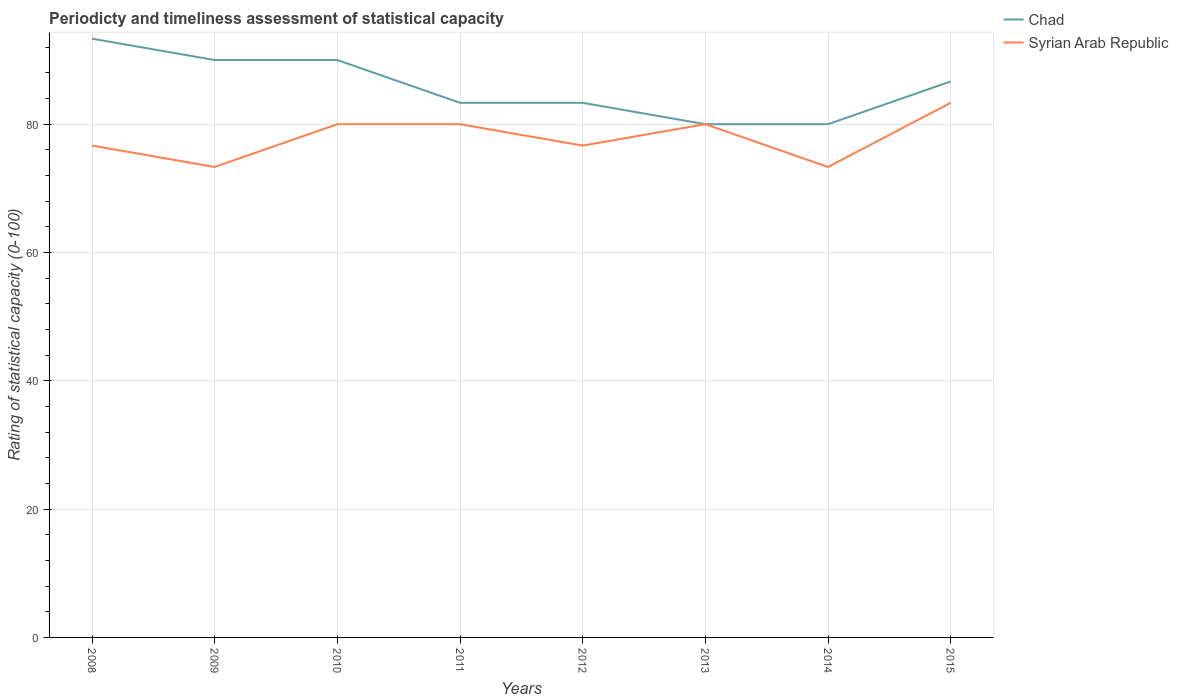Across all years, what is the maximum rating of statistical capacity in Chad?
Offer a very short reply. 80. What is the total rating of statistical capacity in Chad in the graph?
Make the answer very short. -6.67. What is the difference between the highest and the second highest rating of statistical capacity in Chad?
Your answer should be compact. 13.33. What is the difference between the highest and the lowest rating of statistical capacity in Syrian Arab Republic?
Provide a succinct answer. 4. Is the rating of statistical capacity in Chad strictly greater than the rating of statistical capacity in Syrian Arab Republic over the years?
Your response must be concise. No. How many lines are there?
Offer a very short reply. 2. How many years are there in the graph?
Provide a succinct answer. 8. What is the difference between two consecutive major ticks on the Y-axis?
Make the answer very short. 20. Does the graph contain any zero values?
Ensure brevity in your answer.  No. Does the graph contain grids?
Offer a terse response. Yes. How many legend labels are there?
Offer a very short reply. 2. How are the legend labels stacked?
Your response must be concise. Vertical. What is the title of the graph?
Your response must be concise. Periodicty and timeliness assessment of statistical capacity. Does "Australia" appear as one of the legend labels in the graph?
Offer a very short reply. No. What is the label or title of the Y-axis?
Provide a succinct answer. Rating of statistical capacity (0-100). What is the Rating of statistical capacity (0-100) in Chad in 2008?
Offer a terse response. 93.33. What is the Rating of statistical capacity (0-100) in Syrian Arab Republic in 2008?
Give a very brief answer. 76.67. What is the Rating of statistical capacity (0-100) in Chad in 2009?
Your response must be concise. 90. What is the Rating of statistical capacity (0-100) of Syrian Arab Republic in 2009?
Keep it short and to the point. 73.33. What is the Rating of statistical capacity (0-100) of Chad in 2010?
Ensure brevity in your answer.  90. What is the Rating of statistical capacity (0-100) of Chad in 2011?
Provide a succinct answer. 83.33. What is the Rating of statistical capacity (0-100) of Syrian Arab Republic in 2011?
Keep it short and to the point. 80. What is the Rating of statistical capacity (0-100) of Chad in 2012?
Provide a short and direct response. 83.33. What is the Rating of statistical capacity (0-100) in Syrian Arab Republic in 2012?
Provide a short and direct response. 76.67. What is the Rating of statistical capacity (0-100) of Chad in 2013?
Keep it short and to the point. 80. What is the Rating of statistical capacity (0-100) in Syrian Arab Republic in 2013?
Offer a terse response. 80. What is the Rating of statistical capacity (0-100) of Syrian Arab Republic in 2014?
Ensure brevity in your answer.  73.33. What is the Rating of statistical capacity (0-100) in Chad in 2015?
Your response must be concise. 86.67. What is the Rating of statistical capacity (0-100) of Syrian Arab Republic in 2015?
Make the answer very short. 83.33. Across all years, what is the maximum Rating of statistical capacity (0-100) in Chad?
Offer a terse response. 93.33. Across all years, what is the maximum Rating of statistical capacity (0-100) in Syrian Arab Republic?
Provide a succinct answer. 83.33. Across all years, what is the minimum Rating of statistical capacity (0-100) of Syrian Arab Republic?
Keep it short and to the point. 73.33. What is the total Rating of statistical capacity (0-100) of Chad in the graph?
Offer a very short reply. 686.67. What is the total Rating of statistical capacity (0-100) in Syrian Arab Republic in the graph?
Offer a terse response. 623.33. What is the difference between the Rating of statistical capacity (0-100) in Chad in 2008 and that in 2011?
Provide a short and direct response. 10. What is the difference between the Rating of statistical capacity (0-100) in Syrian Arab Republic in 2008 and that in 2011?
Give a very brief answer. -3.33. What is the difference between the Rating of statistical capacity (0-100) of Chad in 2008 and that in 2012?
Your answer should be very brief. 10. What is the difference between the Rating of statistical capacity (0-100) of Syrian Arab Republic in 2008 and that in 2012?
Keep it short and to the point. 0. What is the difference between the Rating of statistical capacity (0-100) in Chad in 2008 and that in 2013?
Offer a very short reply. 13.33. What is the difference between the Rating of statistical capacity (0-100) in Syrian Arab Republic in 2008 and that in 2013?
Provide a succinct answer. -3.33. What is the difference between the Rating of statistical capacity (0-100) in Chad in 2008 and that in 2014?
Your answer should be very brief. 13.33. What is the difference between the Rating of statistical capacity (0-100) in Syrian Arab Republic in 2008 and that in 2014?
Ensure brevity in your answer.  3.33. What is the difference between the Rating of statistical capacity (0-100) of Chad in 2008 and that in 2015?
Offer a terse response. 6.67. What is the difference between the Rating of statistical capacity (0-100) of Syrian Arab Republic in 2008 and that in 2015?
Your response must be concise. -6.67. What is the difference between the Rating of statistical capacity (0-100) of Chad in 2009 and that in 2010?
Your response must be concise. 0. What is the difference between the Rating of statistical capacity (0-100) of Syrian Arab Republic in 2009 and that in 2010?
Ensure brevity in your answer.  -6.67. What is the difference between the Rating of statistical capacity (0-100) of Syrian Arab Republic in 2009 and that in 2011?
Your answer should be compact. -6.67. What is the difference between the Rating of statistical capacity (0-100) in Chad in 2009 and that in 2013?
Give a very brief answer. 10. What is the difference between the Rating of statistical capacity (0-100) in Syrian Arab Republic in 2009 and that in 2013?
Your answer should be very brief. -6.67. What is the difference between the Rating of statistical capacity (0-100) of Chad in 2009 and that in 2014?
Ensure brevity in your answer.  10. What is the difference between the Rating of statistical capacity (0-100) in Syrian Arab Republic in 2009 and that in 2014?
Offer a terse response. -0. What is the difference between the Rating of statistical capacity (0-100) of Chad in 2009 and that in 2015?
Give a very brief answer. 3.33. What is the difference between the Rating of statistical capacity (0-100) in Syrian Arab Republic in 2010 and that in 2011?
Give a very brief answer. 0. What is the difference between the Rating of statistical capacity (0-100) in Chad in 2010 and that in 2012?
Provide a short and direct response. 6.67. What is the difference between the Rating of statistical capacity (0-100) of Syrian Arab Republic in 2010 and that in 2012?
Keep it short and to the point. 3.33. What is the difference between the Rating of statistical capacity (0-100) of Chad in 2010 and that in 2013?
Give a very brief answer. 10. What is the difference between the Rating of statistical capacity (0-100) of Chad in 2010 and that in 2014?
Your response must be concise. 10. What is the difference between the Rating of statistical capacity (0-100) in Syrian Arab Republic in 2010 and that in 2014?
Provide a succinct answer. 6.67. What is the difference between the Rating of statistical capacity (0-100) in Chad in 2010 and that in 2015?
Your response must be concise. 3.33. What is the difference between the Rating of statistical capacity (0-100) in Chad in 2011 and that in 2015?
Make the answer very short. -3.33. What is the difference between the Rating of statistical capacity (0-100) in Syrian Arab Republic in 2012 and that in 2013?
Offer a very short reply. -3.33. What is the difference between the Rating of statistical capacity (0-100) of Chad in 2012 and that in 2014?
Your answer should be compact. 3.33. What is the difference between the Rating of statistical capacity (0-100) in Chad in 2012 and that in 2015?
Give a very brief answer. -3.33. What is the difference between the Rating of statistical capacity (0-100) of Syrian Arab Republic in 2012 and that in 2015?
Offer a terse response. -6.67. What is the difference between the Rating of statistical capacity (0-100) in Chad in 2013 and that in 2014?
Your answer should be compact. 0. What is the difference between the Rating of statistical capacity (0-100) of Syrian Arab Republic in 2013 and that in 2014?
Your answer should be compact. 6.67. What is the difference between the Rating of statistical capacity (0-100) of Chad in 2013 and that in 2015?
Provide a short and direct response. -6.67. What is the difference between the Rating of statistical capacity (0-100) of Syrian Arab Republic in 2013 and that in 2015?
Give a very brief answer. -3.33. What is the difference between the Rating of statistical capacity (0-100) of Chad in 2014 and that in 2015?
Give a very brief answer. -6.67. What is the difference between the Rating of statistical capacity (0-100) in Chad in 2008 and the Rating of statistical capacity (0-100) in Syrian Arab Republic in 2010?
Ensure brevity in your answer.  13.33. What is the difference between the Rating of statistical capacity (0-100) in Chad in 2008 and the Rating of statistical capacity (0-100) in Syrian Arab Republic in 2011?
Offer a terse response. 13.33. What is the difference between the Rating of statistical capacity (0-100) of Chad in 2008 and the Rating of statistical capacity (0-100) of Syrian Arab Republic in 2012?
Provide a succinct answer. 16.67. What is the difference between the Rating of statistical capacity (0-100) in Chad in 2008 and the Rating of statistical capacity (0-100) in Syrian Arab Republic in 2013?
Provide a short and direct response. 13.33. What is the difference between the Rating of statistical capacity (0-100) in Chad in 2008 and the Rating of statistical capacity (0-100) in Syrian Arab Republic in 2015?
Your response must be concise. 10. What is the difference between the Rating of statistical capacity (0-100) of Chad in 2009 and the Rating of statistical capacity (0-100) of Syrian Arab Republic in 2010?
Give a very brief answer. 10. What is the difference between the Rating of statistical capacity (0-100) in Chad in 2009 and the Rating of statistical capacity (0-100) in Syrian Arab Republic in 2011?
Provide a short and direct response. 10. What is the difference between the Rating of statistical capacity (0-100) in Chad in 2009 and the Rating of statistical capacity (0-100) in Syrian Arab Republic in 2012?
Give a very brief answer. 13.33. What is the difference between the Rating of statistical capacity (0-100) of Chad in 2009 and the Rating of statistical capacity (0-100) of Syrian Arab Republic in 2013?
Give a very brief answer. 10. What is the difference between the Rating of statistical capacity (0-100) of Chad in 2009 and the Rating of statistical capacity (0-100) of Syrian Arab Republic in 2014?
Make the answer very short. 16.67. What is the difference between the Rating of statistical capacity (0-100) of Chad in 2009 and the Rating of statistical capacity (0-100) of Syrian Arab Republic in 2015?
Keep it short and to the point. 6.67. What is the difference between the Rating of statistical capacity (0-100) of Chad in 2010 and the Rating of statistical capacity (0-100) of Syrian Arab Republic in 2011?
Offer a terse response. 10. What is the difference between the Rating of statistical capacity (0-100) in Chad in 2010 and the Rating of statistical capacity (0-100) in Syrian Arab Republic in 2012?
Offer a very short reply. 13.33. What is the difference between the Rating of statistical capacity (0-100) in Chad in 2010 and the Rating of statistical capacity (0-100) in Syrian Arab Republic in 2014?
Keep it short and to the point. 16.67. What is the difference between the Rating of statistical capacity (0-100) in Chad in 2010 and the Rating of statistical capacity (0-100) in Syrian Arab Republic in 2015?
Offer a very short reply. 6.67. What is the difference between the Rating of statistical capacity (0-100) of Chad in 2011 and the Rating of statistical capacity (0-100) of Syrian Arab Republic in 2012?
Your answer should be very brief. 6.67. What is the difference between the Rating of statistical capacity (0-100) of Chad in 2011 and the Rating of statistical capacity (0-100) of Syrian Arab Republic in 2013?
Keep it short and to the point. 3.33. What is the difference between the Rating of statistical capacity (0-100) in Chad in 2011 and the Rating of statistical capacity (0-100) in Syrian Arab Republic in 2014?
Your answer should be very brief. 10. What is the difference between the Rating of statistical capacity (0-100) of Chad in 2011 and the Rating of statistical capacity (0-100) of Syrian Arab Republic in 2015?
Provide a succinct answer. 0. What is the difference between the Rating of statistical capacity (0-100) in Chad in 2012 and the Rating of statistical capacity (0-100) in Syrian Arab Republic in 2014?
Your answer should be compact. 10. What is the difference between the Rating of statistical capacity (0-100) in Chad in 2012 and the Rating of statistical capacity (0-100) in Syrian Arab Republic in 2015?
Your response must be concise. 0. What is the difference between the Rating of statistical capacity (0-100) in Chad in 2013 and the Rating of statistical capacity (0-100) in Syrian Arab Republic in 2015?
Ensure brevity in your answer.  -3.33. What is the average Rating of statistical capacity (0-100) in Chad per year?
Provide a short and direct response. 85.83. What is the average Rating of statistical capacity (0-100) in Syrian Arab Republic per year?
Your response must be concise. 77.92. In the year 2008, what is the difference between the Rating of statistical capacity (0-100) of Chad and Rating of statistical capacity (0-100) of Syrian Arab Republic?
Your response must be concise. 16.67. In the year 2009, what is the difference between the Rating of statistical capacity (0-100) in Chad and Rating of statistical capacity (0-100) in Syrian Arab Republic?
Give a very brief answer. 16.67. In the year 2010, what is the difference between the Rating of statistical capacity (0-100) of Chad and Rating of statistical capacity (0-100) of Syrian Arab Republic?
Provide a short and direct response. 10. In the year 2011, what is the difference between the Rating of statistical capacity (0-100) in Chad and Rating of statistical capacity (0-100) in Syrian Arab Republic?
Provide a succinct answer. 3.33. In the year 2012, what is the difference between the Rating of statistical capacity (0-100) in Chad and Rating of statistical capacity (0-100) in Syrian Arab Republic?
Provide a short and direct response. 6.67. In the year 2013, what is the difference between the Rating of statistical capacity (0-100) of Chad and Rating of statistical capacity (0-100) of Syrian Arab Republic?
Provide a short and direct response. 0. In the year 2015, what is the difference between the Rating of statistical capacity (0-100) in Chad and Rating of statistical capacity (0-100) in Syrian Arab Republic?
Make the answer very short. 3.33. What is the ratio of the Rating of statistical capacity (0-100) of Syrian Arab Republic in 2008 to that in 2009?
Your answer should be compact. 1.05. What is the ratio of the Rating of statistical capacity (0-100) in Syrian Arab Republic in 2008 to that in 2010?
Offer a very short reply. 0.96. What is the ratio of the Rating of statistical capacity (0-100) in Chad in 2008 to that in 2011?
Make the answer very short. 1.12. What is the ratio of the Rating of statistical capacity (0-100) of Chad in 2008 to that in 2012?
Provide a short and direct response. 1.12. What is the ratio of the Rating of statistical capacity (0-100) in Syrian Arab Republic in 2008 to that in 2013?
Provide a succinct answer. 0.96. What is the ratio of the Rating of statistical capacity (0-100) in Chad in 2008 to that in 2014?
Provide a short and direct response. 1.17. What is the ratio of the Rating of statistical capacity (0-100) of Syrian Arab Republic in 2008 to that in 2014?
Keep it short and to the point. 1.05. What is the ratio of the Rating of statistical capacity (0-100) in Chad in 2008 to that in 2015?
Give a very brief answer. 1.08. What is the ratio of the Rating of statistical capacity (0-100) of Chad in 2009 to that in 2011?
Your response must be concise. 1.08. What is the ratio of the Rating of statistical capacity (0-100) of Syrian Arab Republic in 2009 to that in 2012?
Keep it short and to the point. 0.96. What is the ratio of the Rating of statistical capacity (0-100) in Syrian Arab Republic in 2009 to that in 2013?
Keep it short and to the point. 0.92. What is the ratio of the Rating of statistical capacity (0-100) in Chad in 2009 to that in 2015?
Your answer should be very brief. 1.04. What is the ratio of the Rating of statistical capacity (0-100) of Syrian Arab Republic in 2009 to that in 2015?
Ensure brevity in your answer.  0.88. What is the ratio of the Rating of statistical capacity (0-100) of Chad in 2010 to that in 2011?
Ensure brevity in your answer.  1.08. What is the ratio of the Rating of statistical capacity (0-100) of Chad in 2010 to that in 2012?
Ensure brevity in your answer.  1.08. What is the ratio of the Rating of statistical capacity (0-100) of Syrian Arab Republic in 2010 to that in 2012?
Ensure brevity in your answer.  1.04. What is the ratio of the Rating of statistical capacity (0-100) in Chad in 2010 to that in 2015?
Give a very brief answer. 1.04. What is the ratio of the Rating of statistical capacity (0-100) in Chad in 2011 to that in 2012?
Provide a succinct answer. 1. What is the ratio of the Rating of statistical capacity (0-100) of Syrian Arab Republic in 2011 to that in 2012?
Your response must be concise. 1.04. What is the ratio of the Rating of statistical capacity (0-100) of Chad in 2011 to that in 2013?
Provide a succinct answer. 1.04. What is the ratio of the Rating of statistical capacity (0-100) of Chad in 2011 to that in 2014?
Keep it short and to the point. 1.04. What is the ratio of the Rating of statistical capacity (0-100) in Syrian Arab Republic in 2011 to that in 2014?
Keep it short and to the point. 1.09. What is the ratio of the Rating of statistical capacity (0-100) in Chad in 2011 to that in 2015?
Offer a very short reply. 0.96. What is the ratio of the Rating of statistical capacity (0-100) of Syrian Arab Republic in 2011 to that in 2015?
Provide a short and direct response. 0.96. What is the ratio of the Rating of statistical capacity (0-100) in Chad in 2012 to that in 2013?
Offer a terse response. 1.04. What is the ratio of the Rating of statistical capacity (0-100) of Syrian Arab Republic in 2012 to that in 2013?
Offer a terse response. 0.96. What is the ratio of the Rating of statistical capacity (0-100) of Chad in 2012 to that in 2014?
Offer a terse response. 1.04. What is the ratio of the Rating of statistical capacity (0-100) in Syrian Arab Republic in 2012 to that in 2014?
Provide a short and direct response. 1.05. What is the ratio of the Rating of statistical capacity (0-100) of Chad in 2012 to that in 2015?
Keep it short and to the point. 0.96. What is the ratio of the Rating of statistical capacity (0-100) in Syrian Arab Republic in 2012 to that in 2015?
Your response must be concise. 0.92. What is the ratio of the Rating of statistical capacity (0-100) of Syrian Arab Republic in 2013 to that in 2014?
Your response must be concise. 1.09. What is the ratio of the Rating of statistical capacity (0-100) of Chad in 2013 to that in 2015?
Ensure brevity in your answer.  0.92. What is the ratio of the Rating of statistical capacity (0-100) in Syrian Arab Republic in 2013 to that in 2015?
Offer a terse response. 0.96. What is the ratio of the Rating of statistical capacity (0-100) of Syrian Arab Republic in 2014 to that in 2015?
Offer a very short reply. 0.88. What is the difference between the highest and the lowest Rating of statistical capacity (0-100) of Chad?
Your response must be concise. 13.33. What is the difference between the highest and the lowest Rating of statistical capacity (0-100) of Syrian Arab Republic?
Your answer should be very brief. 10. 